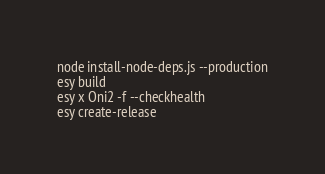<code> <loc_0><loc_0><loc_500><loc_500><_Bash_>node install-node-deps.js --production
esy build
esy x Oni2 -f --checkhealth
esy create-release
</code> 